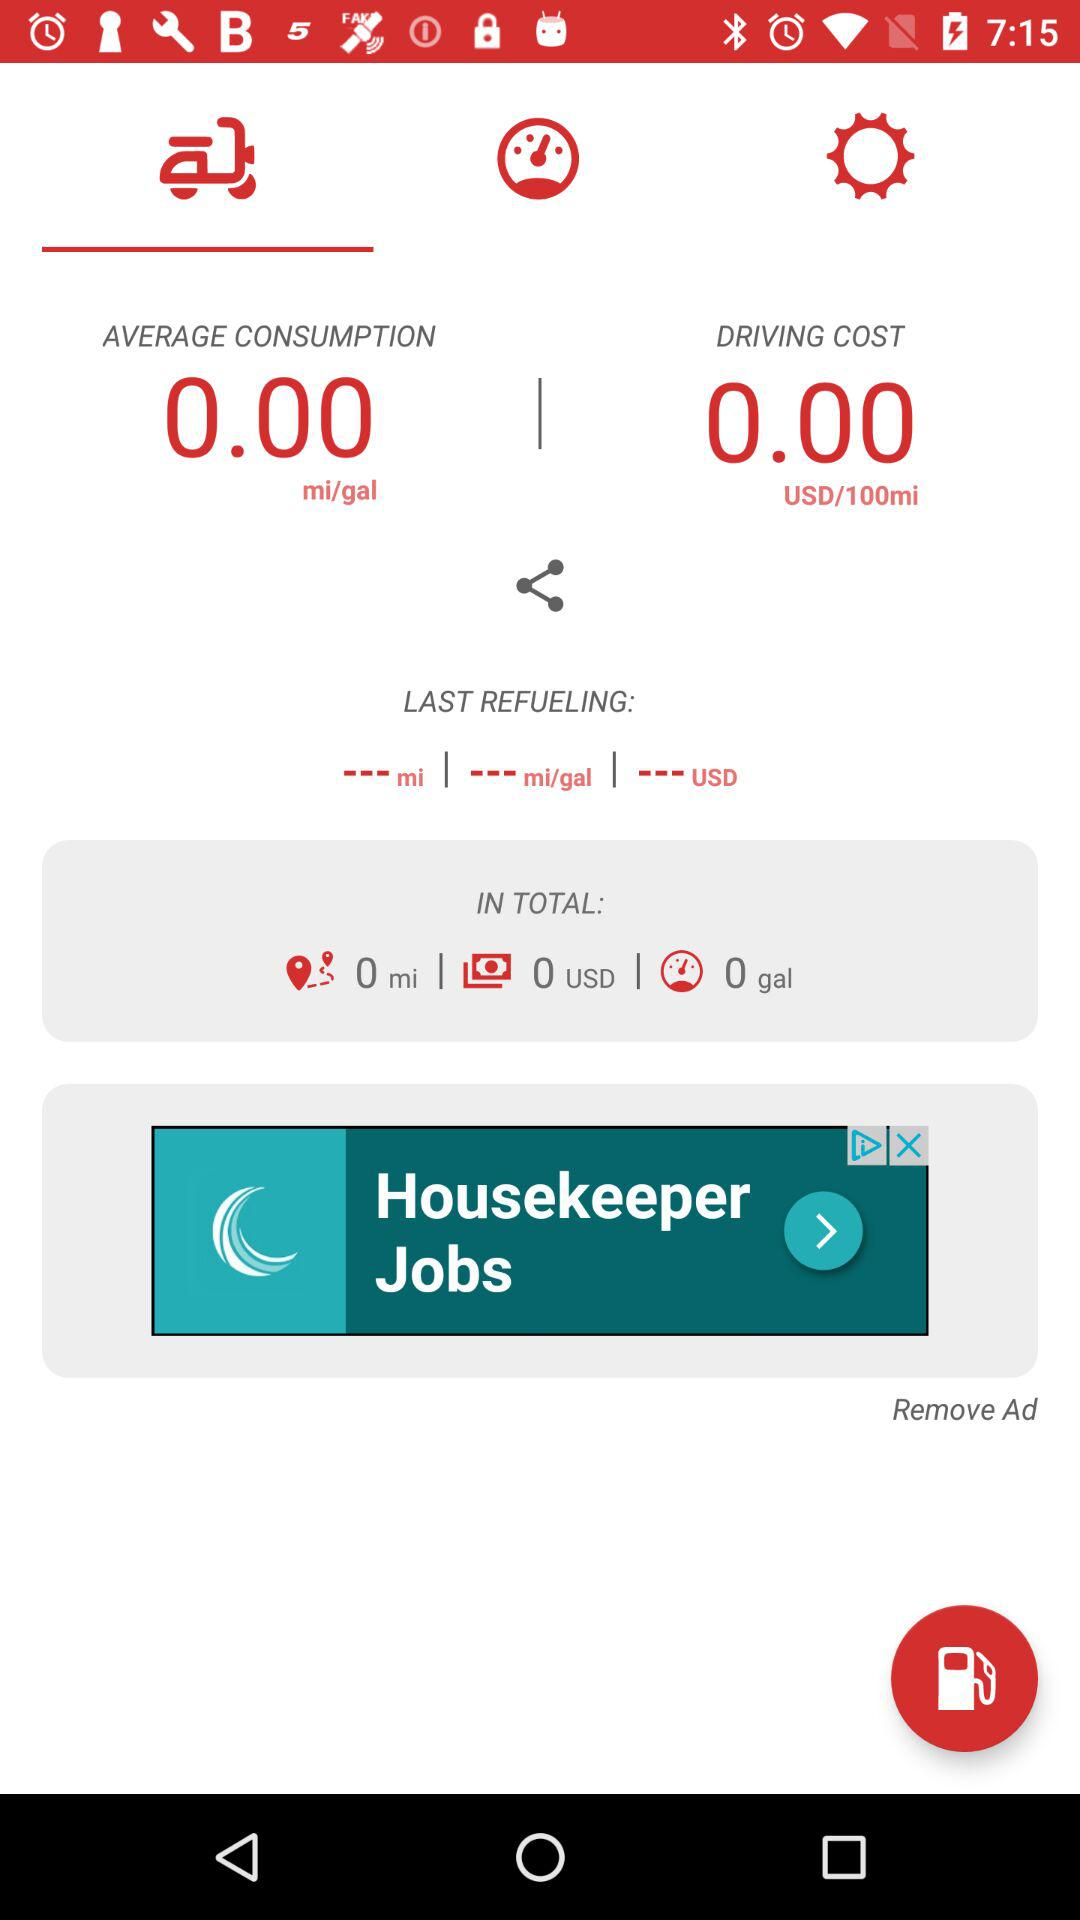What is the status of refueling in total?
When the provided information is insufficient, respond with <no answer>. <no answer> 